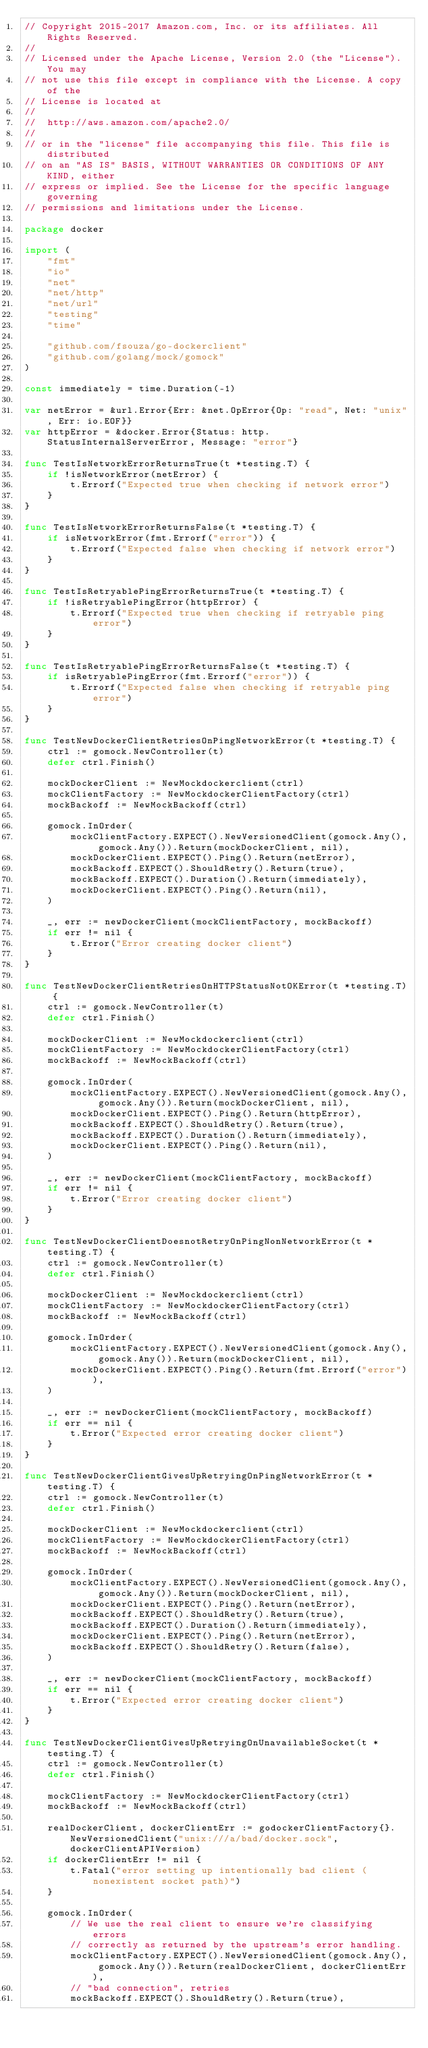<code> <loc_0><loc_0><loc_500><loc_500><_Go_>// Copyright 2015-2017 Amazon.com, Inc. or its affiliates. All Rights Reserved.
//
// Licensed under the Apache License, Version 2.0 (the "License"). You may
// not use this file except in compliance with the License. A copy of the
// License is located at
//
//	http://aws.amazon.com/apache2.0/
//
// or in the "license" file accompanying this file. This file is distributed
// on an "AS IS" BASIS, WITHOUT WARRANTIES OR CONDITIONS OF ANY KIND, either
// express or implied. See the License for the specific language governing
// permissions and limitations under the License.

package docker

import (
	"fmt"
	"io"
	"net"
	"net/http"
	"net/url"
	"testing"
	"time"

	"github.com/fsouza/go-dockerclient"
	"github.com/golang/mock/gomock"
)

const immediately = time.Duration(-1)

var netError = &url.Error{Err: &net.OpError{Op: "read", Net: "unix", Err: io.EOF}}
var httpError = &docker.Error{Status: http.StatusInternalServerError, Message: "error"}

func TestIsNetworkErrorReturnsTrue(t *testing.T) {
	if !isNetworkError(netError) {
		t.Errorf("Expected true when checking if network error")
	}
}

func TestIsNetworkErrorReturnsFalse(t *testing.T) {
	if isNetworkError(fmt.Errorf("error")) {
		t.Errorf("Expected false when checking if network error")
	}
}

func TestIsRetryablePingErrorReturnsTrue(t *testing.T) {
	if !isRetryablePingError(httpError) {
		t.Errorf("Expected true when checking if retryable ping error")
	}
}

func TestIsRetryablePingErrorReturnsFalse(t *testing.T) {
	if isRetryablePingError(fmt.Errorf("error")) {
		t.Errorf("Expected false when checking if retryable ping error")
	}
}

func TestNewDockerClientRetriesOnPingNetworkError(t *testing.T) {
	ctrl := gomock.NewController(t)
	defer ctrl.Finish()

	mockDockerClient := NewMockdockerclient(ctrl)
	mockClientFactory := NewMockdockerClientFactory(ctrl)
	mockBackoff := NewMockBackoff(ctrl)

	gomock.InOrder(
		mockClientFactory.EXPECT().NewVersionedClient(gomock.Any(), gomock.Any()).Return(mockDockerClient, nil),
		mockDockerClient.EXPECT().Ping().Return(netError),
		mockBackoff.EXPECT().ShouldRetry().Return(true),
		mockBackoff.EXPECT().Duration().Return(immediately),
		mockDockerClient.EXPECT().Ping().Return(nil),
	)

	_, err := newDockerClient(mockClientFactory, mockBackoff)
	if err != nil {
		t.Error("Error creating docker client")
	}
}

func TestNewDockerClientRetriesOnHTTPStatusNotOKError(t *testing.T) {
	ctrl := gomock.NewController(t)
	defer ctrl.Finish()

	mockDockerClient := NewMockdockerclient(ctrl)
	mockClientFactory := NewMockdockerClientFactory(ctrl)
	mockBackoff := NewMockBackoff(ctrl)

	gomock.InOrder(
		mockClientFactory.EXPECT().NewVersionedClient(gomock.Any(), gomock.Any()).Return(mockDockerClient, nil),
		mockDockerClient.EXPECT().Ping().Return(httpError),
		mockBackoff.EXPECT().ShouldRetry().Return(true),
		mockBackoff.EXPECT().Duration().Return(immediately),
		mockDockerClient.EXPECT().Ping().Return(nil),
	)

	_, err := newDockerClient(mockClientFactory, mockBackoff)
	if err != nil {
		t.Error("Error creating docker client")
	}
}

func TestNewDockerClientDoesnotRetryOnPingNonNetworkError(t *testing.T) {
	ctrl := gomock.NewController(t)
	defer ctrl.Finish()

	mockDockerClient := NewMockdockerclient(ctrl)
	mockClientFactory := NewMockdockerClientFactory(ctrl)
	mockBackoff := NewMockBackoff(ctrl)

	gomock.InOrder(
		mockClientFactory.EXPECT().NewVersionedClient(gomock.Any(), gomock.Any()).Return(mockDockerClient, nil),
		mockDockerClient.EXPECT().Ping().Return(fmt.Errorf("error")),
	)

	_, err := newDockerClient(mockClientFactory, mockBackoff)
	if err == nil {
		t.Error("Expected error creating docker client")
	}
}

func TestNewDockerClientGivesUpRetryingOnPingNetworkError(t *testing.T) {
	ctrl := gomock.NewController(t)
	defer ctrl.Finish()

	mockDockerClient := NewMockdockerclient(ctrl)
	mockClientFactory := NewMockdockerClientFactory(ctrl)
	mockBackoff := NewMockBackoff(ctrl)

	gomock.InOrder(
		mockClientFactory.EXPECT().NewVersionedClient(gomock.Any(), gomock.Any()).Return(mockDockerClient, nil),
		mockDockerClient.EXPECT().Ping().Return(netError),
		mockBackoff.EXPECT().ShouldRetry().Return(true),
		mockBackoff.EXPECT().Duration().Return(immediately),
		mockDockerClient.EXPECT().Ping().Return(netError),
		mockBackoff.EXPECT().ShouldRetry().Return(false),
	)

	_, err := newDockerClient(mockClientFactory, mockBackoff)
	if err == nil {
		t.Error("Expected error creating docker client")
	}
}

func TestNewDockerClientGivesUpRetryingOnUnavailableSocket(t *testing.T) {
	ctrl := gomock.NewController(t)
	defer ctrl.Finish()

	mockClientFactory := NewMockdockerClientFactory(ctrl)
	mockBackoff := NewMockBackoff(ctrl)

	realDockerClient, dockerClientErr := godockerClientFactory{}.NewVersionedClient("unix:///a/bad/docker.sock", dockerClientAPIVersion)
	if dockerClientErr != nil {
		t.Fatal("error setting up intentionally bad client (nonexistent socket path)")
	}

	gomock.InOrder(
		// We use the real client to ensure we're classifying errors
		// correctly as returned by the upstream's error handling.
		mockClientFactory.EXPECT().NewVersionedClient(gomock.Any(), gomock.Any()).Return(realDockerClient, dockerClientErr),
		// "bad connection", retries
		mockBackoff.EXPECT().ShouldRetry().Return(true),</code> 